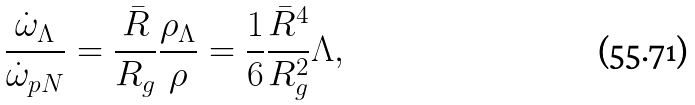Convert formula to latex. <formula><loc_0><loc_0><loc_500><loc_500>\frac { \dot { \omega } _ { \Lambda } } { \dot { \omega } _ { p N } } = \frac { \bar { R } } { R _ { g } } \frac { \rho _ { \Lambda } } { \rho } = \frac { 1 } { 6 } \frac { \bar { R } ^ { 4 } } { R _ { g } ^ { 2 } } \Lambda ,</formula> 